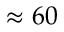<formula> <loc_0><loc_0><loc_500><loc_500>\approx 6 0</formula> 